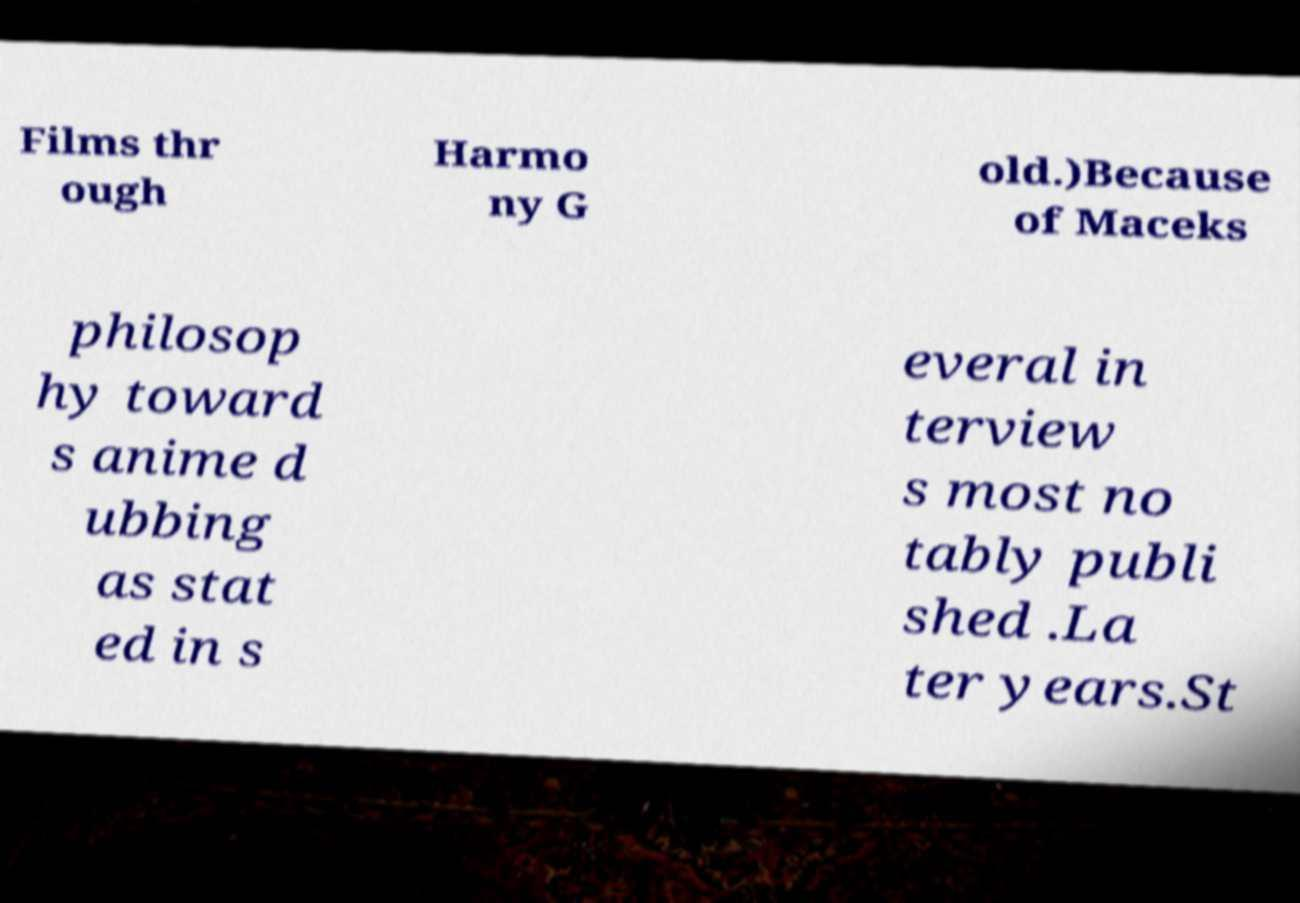Can you read and provide the text displayed in the image?This photo seems to have some interesting text. Can you extract and type it out for me? Films thr ough Harmo ny G old.)Because of Maceks philosop hy toward s anime d ubbing as stat ed in s everal in terview s most no tably publi shed .La ter years.St 